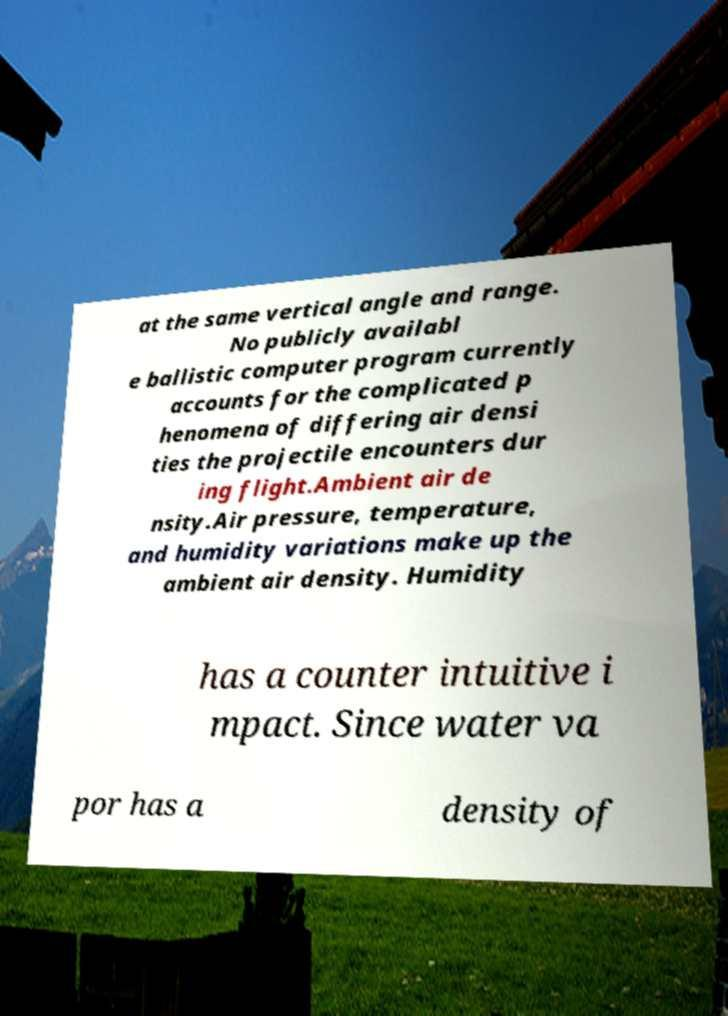What messages or text are displayed in this image? I need them in a readable, typed format. at the same vertical angle and range. No publicly availabl e ballistic computer program currently accounts for the complicated p henomena of differing air densi ties the projectile encounters dur ing flight.Ambient air de nsity.Air pressure, temperature, and humidity variations make up the ambient air density. Humidity has a counter intuitive i mpact. Since water va por has a density of 